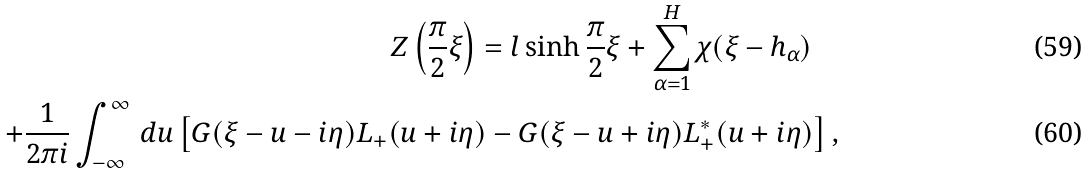Convert formula to latex. <formula><loc_0><loc_0><loc_500><loc_500>Z \left ( \frac { \pi } { 2 } \xi \right ) = l \sinh \frac { \pi } { 2 } \xi + \sum _ { \alpha = 1 } ^ { H } \chi ( \xi - h _ { \alpha } ) \quad \\ + \frac { 1 } { 2 \pi i } \int _ { - \infty } ^ { \infty } \, d u \left [ G ( \xi - u - i \eta ) L _ { + } ( u + i \eta ) - G ( \xi - u + i \eta ) L _ { + } ^ { * } ( u + i \eta ) \right ] ,</formula> 